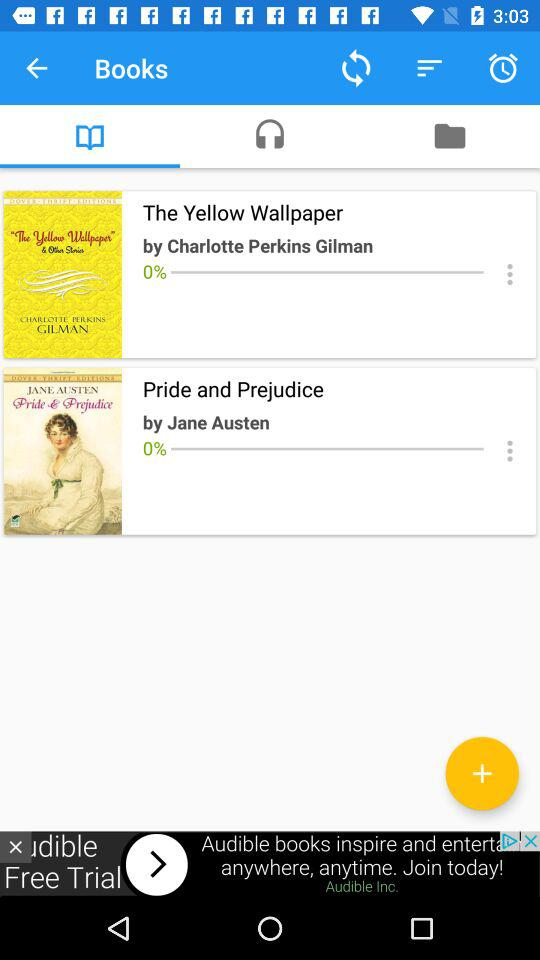What is the download percentage of "The Yellow Wallpaper" book? The download percentage is 0. 